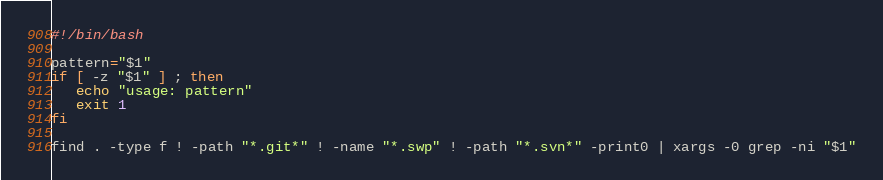<code> <loc_0><loc_0><loc_500><loc_500><_Bash_>#!/bin/bash

pattern="$1"
if [ -z "$1" ] ; then
   echo "usage: pattern"
   exit 1
fi

find . -type f ! -path "*.git*" ! -name "*.swp" ! -path "*.svn*" -print0 | xargs -0 grep -ni "$1"
</code> 